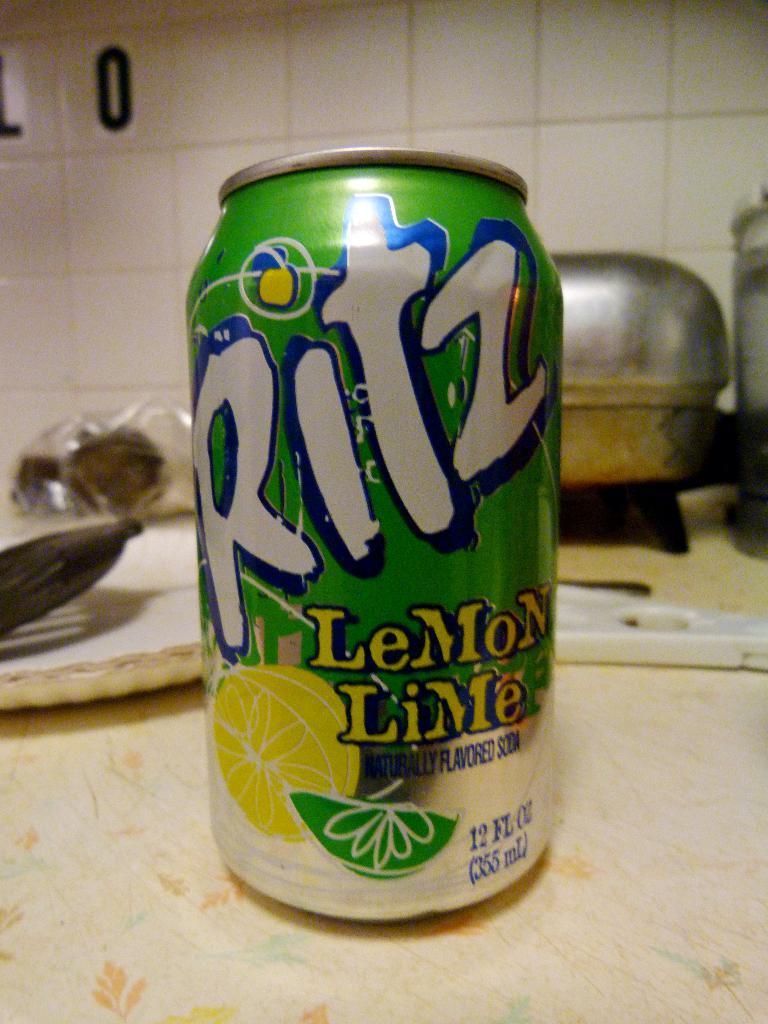In one or two sentences, can you explain what this image depicts? In this picture there is a tin and there are disposable plates and there are utensils on the table. At the back there are tiles on the wall. 